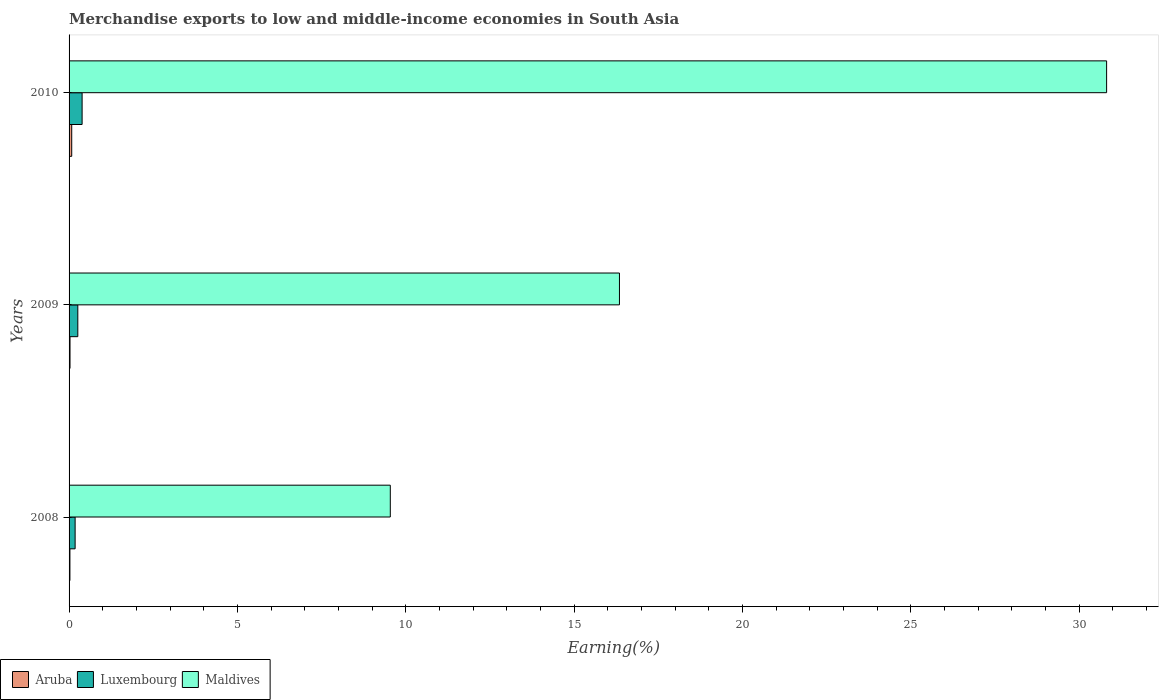How many different coloured bars are there?
Make the answer very short. 3. In how many cases, is the number of bars for a given year not equal to the number of legend labels?
Provide a short and direct response. 0. What is the percentage of amount earned from merchandise exports in Luxembourg in 2010?
Offer a very short reply. 0.39. Across all years, what is the maximum percentage of amount earned from merchandise exports in Maldives?
Offer a very short reply. 30.81. Across all years, what is the minimum percentage of amount earned from merchandise exports in Aruba?
Offer a very short reply. 0.03. In which year was the percentage of amount earned from merchandise exports in Luxembourg maximum?
Provide a succinct answer. 2010. What is the total percentage of amount earned from merchandise exports in Aruba in the graph?
Offer a very short reply. 0.13. What is the difference between the percentage of amount earned from merchandise exports in Luxembourg in 2008 and that in 2009?
Your response must be concise. -0.08. What is the difference between the percentage of amount earned from merchandise exports in Maldives in 2009 and the percentage of amount earned from merchandise exports in Luxembourg in 2008?
Ensure brevity in your answer.  16.17. What is the average percentage of amount earned from merchandise exports in Luxembourg per year?
Provide a succinct answer. 0.28. In the year 2010, what is the difference between the percentage of amount earned from merchandise exports in Maldives and percentage of amount earned from merchandise exports in Luxembourg?
Provide a short and direct response. 30.43. What is the ratio of the percentage of amount earned from merchandise exports in Luxembourg in 2009 to that in 2010?
Offer a terse response. 0.67. What is the difference between the highest and the second highest percentage of amount earned from merchandise exports in Aruba?
Make the answer very short. 0.05. What is the difference between the highest and the lowest percentage of amount earned from merchandise exports in Aruba?
Your answer should be very brief. 0.05. In how many years, is the percentage of amount earned from merchandise exports in Aruba greater than the average percentage of amount earned from merchandise exports in Aruba taken over all years?
Offer a terse response. 1. What does the 2nd bar from the top in 2010 represents?
Your answer should be compact. Luxembourg. What does the 1st bar from the bottom in 2010 represents?
Keep it short and to the point. Aruba. How many bars are there?
Provide a succinct answer. 9. Are all the bars in the graph horizontal?
Provide a succinct answer. Yes. Are the values on the major ticks of X-axis written in scientific E-notation?
Offer a terse response. No. Does the graph contain any zero values?
Ensure brevity in your answer.  No. Does the graph contain grids?
Your answer should be very brief. No. How many legend labels are there?
Keep it short and to the point. 3. How are the legend labels stacked?
Your response must be concise. Horizontal. What is the title of the graph?
Your answer should be very brief. Merchandise exports to low and middle-income economies in South Asia. Does "Caribbean small states" appear as one of the legend labels in the graph?
Your answer should be very brief. No. What is the label or title of the X-axis?
Make the answer very short. Earning(%). What is the Earning(%) of Aruba in 2008?
Ensure brevity in your answer.  0.03. What is the Earning(%) of Luxembourg in 2008?
Give a very brief answer. 0.18. What is the Earning(%) of Maldives in 2008?
Your answer should be compact. 9.54. What is the Earning(%) of Aruba in 2009?
Your answer should be very brief. 0.03. What is the Earning(%) in Luxembourg in 2009?
Provide a short and direct response. 0.26. What is the Earning(%) in Maldives in 2009?
Provide a succinct answer. 16.35. What is the Earning(%) of Aruba in 2010?
Make the answer very short. 0.08. What is the Earning(%) in Luxembourg in 2010?
Make the answer very short. 0.39. What is the Earning(%) of Maldives in 2010?
Your answer should be very brief. 30.81. Across all years, what is the maximum Earning(%) in Aruba?
Give a very brief answer. 0.08. Across all years, what is the maximum Earning(%) in Luxembourg?
Give a very brief answer. 0.39. Across all years, what is the maximum Earning(%) in Maldives?
Offer a very short reply. 30.81. Across all years, what is the minimum Earning(%) in Aruba?
Offer a terse response. 0.03. Across all years, what is the minimum Earning(%) of Luxembourg?
Provide a succinct answer. 0.18. Across all years, what is the minimum Earning(%) of Maldives?
Provide a succinct answer. 9.54. What is the total Earning(%) in Aruba in the graph?
Make the answer very short. 0.13. What is the total Earning(%) of Luxembourg in the graph?
Your answer should be very brief. 0.83. What is the total Earning(%) in Maldives in the graph?
Provide a succinct answer. 56.7. What is the difference between the Earning(%) of Aruba in 2008 and that in 2009?
Your response must be concise. -0. What is the difference between the Earning(%) in Luxembourg in 2008 and that in 2009?
Offer a very short reply. -0.08. What is the difference between the Earning(%) in Maldives in 2008 and that in 2009?
Your answer should be very brief. -6.81. What is the difference between the Earning(%) of Aruba in 2008 and that in 2010?
Your answer should be compact. -0.05. What is the difference between the Earning(%) of Luxembourg in 2008 and that in 2010?
Offer a very short reply. -0.21. What is the difference between the Earning(%) of Maldives in 2008 and that in 2010?
Make the answer very short. -21.27. What is the difference between the Earning(%) of Aruba in 2009 and that in 2010?
Offer a very short reply. -0.05. What is the difference between the Earning(%) in Luxembourg in 2009 and that in 2010?
Your response must be concise. -0.13. What is the difference between the Earning(%) of Maldives in 2009 and that in 2010?
Ensure brevity in your answer.  -14.47. What is the difference between the Earning(%) in Aruba in 2008 and the Earning(%) in Luxembourg in 2009?
Ensure brevity in your answer.  -0.23. What is the difference between the Earning(%) in Aruba in 2008 and the Earning(%) in Maldives in 2009?
Ensure brevity in your answer.  -16.32. What is the difference between the Earning(%) of Luxembourg in 2008 and the Earning(%) of Maldives in 2009?
Provide a short and direct response. -16.17. What is the difference between the Earning(%) in Aruba in 2008 and the Earning(%) in Luxembourg in 2010?
Ensure brevity in your answer.  -0.36. What is the difference between the Earning(%) of Aruba in 2008 and the Earning(%) of Maldives in 2010?
Give a very brief answer. -30.79. What is the difference between the Earning(%) of Luxembourg in 2008 and the Earning(%) of Maldives in 2010?
Provide a succinct answer. -30.63. What is the difference between the Earning(%) in Aruba in 2009 and the Earning(%) in Luxembourg in 2010?
Your answer should be very brief. -0.36. What is the difference between the Earning(%) of Aruba in 2009 and the Earning(%) of Maldives in 2010?
Offer a terse response. -30.78. What is the difference between the Earning(%) of Luxembourg in 2009 and the Earning(%) of Maldives in 2010?
Make the answer very short. -30.55. What is the average Earning(%) of Aruba per year?
Keep it short and to the point. 0.04. What is the average Earning(%) in Luxembourg per year?
Your response must be concise. 0.28. What is the average Earning(%) in Maldives per year?
Provide a short and direct response. 18.9. In the year 2008, what is the difference between the Earning(%) in Aruba and Earning(%) in Luxembourg?
Provide a succinct answer. -0.15. In the year 2008, what is the difference between the Earning(%) of Aruba and Earning(%) of Maldives?
Give a very brief answer. -9.51. In the year 2008, what is the difference between the Earning(%) in Luxembourg and Earning(%) in Maldives?
Make the answer very short. -9.36. In the year 2009, what is the difference between the Earning(%) of Aruba and Earning(%) of Luxembourg?
Provide a succinct answer. -0.23. In the year 2009, what is the difference between the Earning(%) in Aruba and Earning(%) in Maldives?
Give a very brief answer. -16.32. In the year 2009, what is the difference between the Earning(%) in Luxembourg and Earning(%) in Maldives?
Your answer should be very brief. -16.09. In the year 2010, what is the difference between the Earning(%) of Aruba and Earning(%) of Luxembourg?
Ensure brevity in your answer.  -0.31. In the year 2010, what is the difference between the Earning(%) in Aruba and Earning(%) in Maldives?
Provide a short and direct response. -30.73. In the year 2010, what is the difference between the Earning(%) in Luxembourg and Earning(%) in Maldives?
Provide a short and direct response. -30.43. What is the ratio of the Earning(%) of Aruba in 2008 to that in 2009?
Provide a short and direct response. 0.9. What is the ratio of the Earning(%) of Luxembourg in 2008 to that in 2009?
Offer a very short reply. 0.69. What is the ratio of the Earning(%) in Maldives in 2008 to that in 2009?
Ensure brevity in your answer.  0.58. What is the ratio of the Earning(%) in Aruba in 2008 to that in 2010?
Your answer should be compact. 0.32. What is the ratio of the Earning(%) of Luxembourg in 2008 to that in 2010?
Provide a short and direct response. 0.46. What is the ratio of the Earning(%) in Maldives in 2008 to that in 2010?
Provide a succinct answer. 0.31. What is the ratio of the Earning(%) in Aruba in 2009 to that in 2010?
Offer a very short reply. 0.36. What is the ratio of the Earning(%) in Luxembourg in 2009 to that in 2010?
Provide a succinct answer. 0.67. What is the ratio of the Earning(%) of Maldives in 2009 to that in 2010?
Offer a terse response. 0.53. What is the difference between the highest and the second highest Earning(%) in Aruba?
Make the answer very short. 0.05. What is the difference between the highest and the second highest Earning(%) of Luxembourg?
Make the answer very short. 0.13. What is the difference between the highest and the second highest Earning(%) of Maldives?
Your answer should be very brief. 14.47. What is the difference between the highest and the lowest Earning(%) in Aruba?
Provide a succinct answer. 0.05. What is the difference between the highest and the lowest Earning(%) in Luxembourg?
Provide a succinct answer. 0.21. What is the difference between the highest and the lowest Earning(%) of Maldives?
Provide a succinct answer. 21.27. 